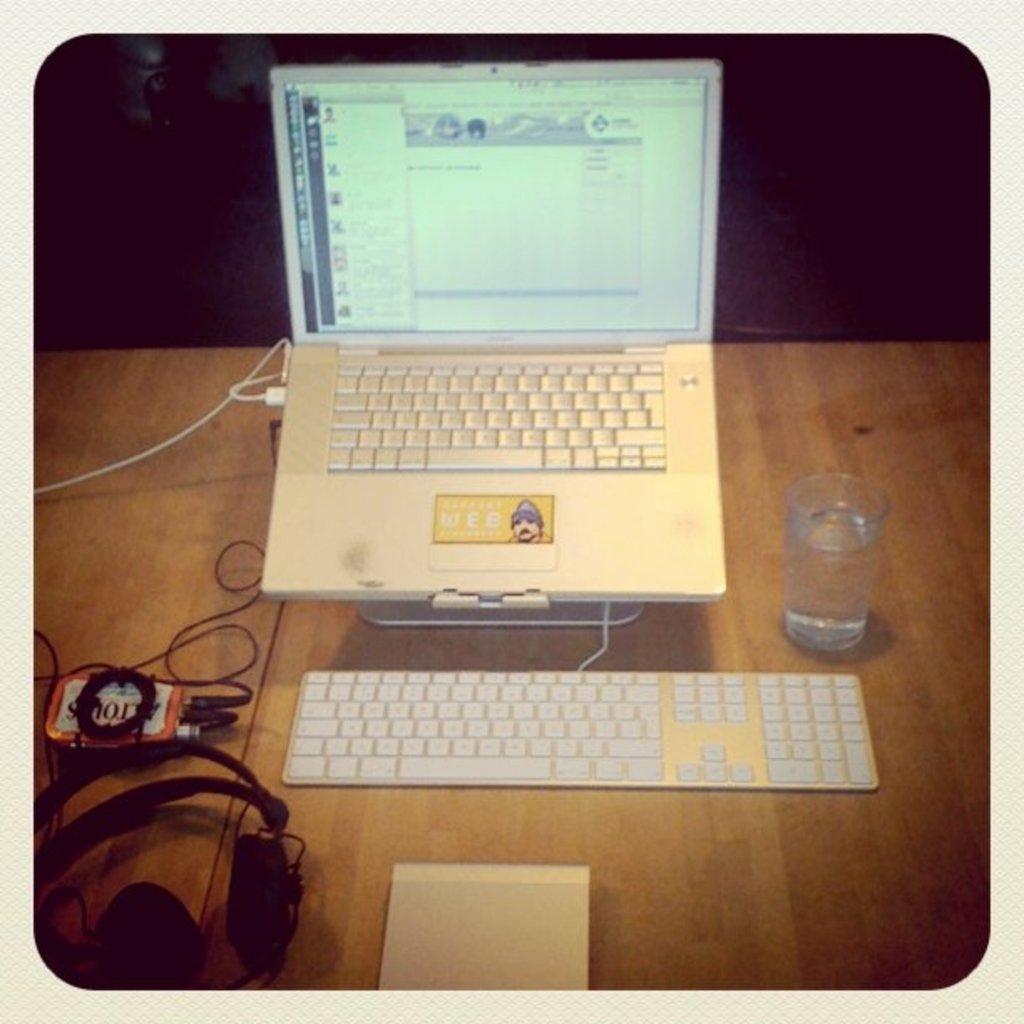What red mint tin is shown here?
Your response must be concise. Altoids. How many keyboards are there?
Offer a terse response. 2. 